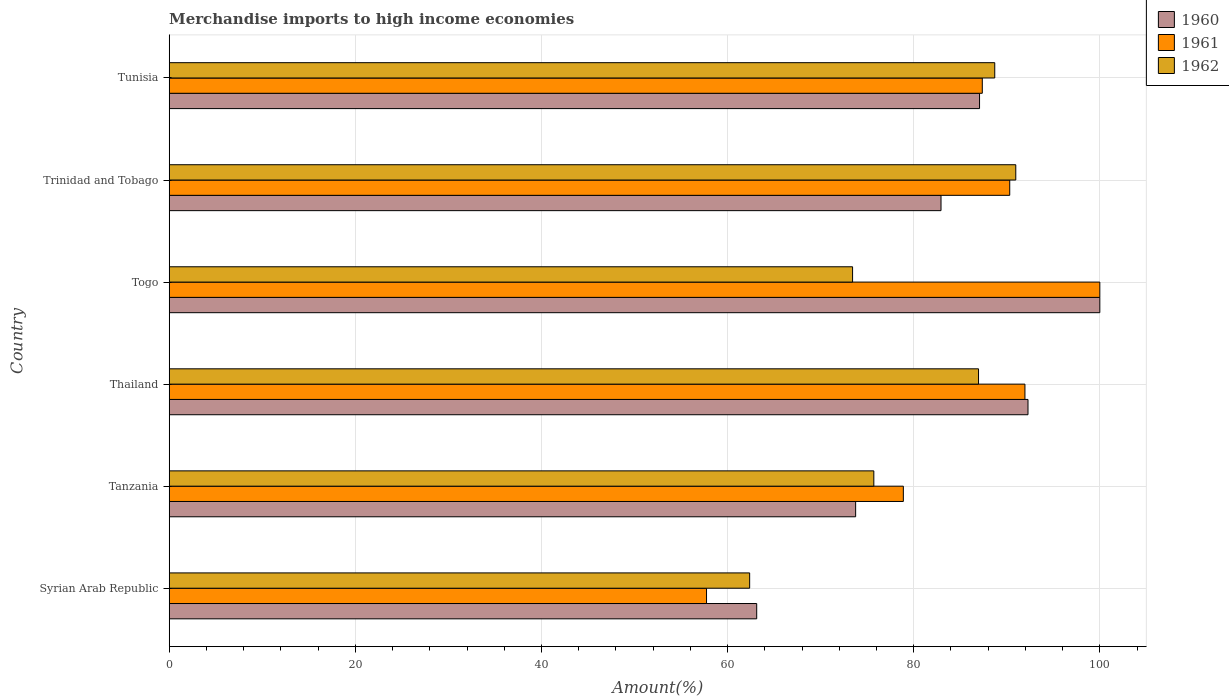How many different coloured bars are there?
Offer a very short reply. 3. How many bars are there on the 6th tick from the top?
Give a very brief answer. 3. How many bars are there on the 5th tick from the bottom?
Offer a very short reply. 3. What is the label of the 3rd group of bars from the top?
Your answer should be compact. Togo. In how many cases, is the number of bars for a given country not equal to the number of legend labels?
Keep it short and to the point. 0. What is the percentage of amount earned from merchandise imports in 1962 in Togo?
Your response must be concise. 73.43. Across all countries, what is the minimum percentage of amount earned from merchandise imports in 1961?
Make the answer very short. 57.74. In which country was the percentage of amount earned from merchandise imports in 1960 maximum?
Make the answer very short. Togo. In which country was the percentage of amount earned from merchandise imports in 1961 minimum?
Offer a terse response. Syrian Arab Republic. What is the total percentage of amount earned from merchandise imports in 1961 in the graph?
Keep it short and to the point. 506.26. What is the difference between the percentage of amount earned from merchandise imports in 1960 in Syrian Arab Republic and that in Tunisia?
Offer a very short reply. -23.95. What is the difference between the percentage of amount earned from merchandise imports in 1961 in Thailand and the percentage of amount earned from merchandise imports in 1962 in Trinidad and Tobago?
Your answer should be compact. 0.98. What is the average percentage of amount earned from merchandise imports in 1961 per country?
Your answer should be very brief. 84.38. What is the difference between the percentage of amount earned from merchandise imports in 1962 and percentage of amount earned from merchandise imports in 1961 in Tunisia?
Your response must be concise. 1.34. What is the ratio of the percentage of amount earned from merchandise imports in 1961 in Trinidad and Tobago to that in Tunisia?
Your answer should be compact. 1.03. Is the percentage of amount earned from merchandise imports in 1961 in Tanzania less than that in Tunisia?
Your answer should be very brief. Yes. Is the difference between the percentage of amount earned from merchandise imports in 1962 in Tanzania and Tunisia greater than the difference between the percentage of amount earned from merchandise imports in 1961 in Tanzania and Tunisia?
Ensure brevity in your answer.  No. What is the difference between the highest and the second highest percentage of amount earned from merchandise imports in 1960?
Your response must be concise. 7.72. What is the difference between the highest and the lowest percentage of amount earned from merchandise imports in 1961?
Your answer should be very brief. 42.26. Is the sum of the percentage of amount earned from merchandise imports in 1962 in Syrian Arab Republic and Thailand greater than the maximum percentage of amount earned from merchandise imports in 1961 across all countries?
Provide a succinct answer. Yes. Is it the case that in every country, the sum of the percentage of amount earned from merchandise imports in 1962 and percentage of amount earned from merchandise imports in 1961 is greater than the percentage of amount earned from merchandise imports in 1960?
Make the answer very short. Yes. How many bars are there?
Provide a short and direct response. 18. Are the values on the major ticks of X-axis written in scientific E-notation?
Keep it short and to the point. No. Does the graph contain any zero values?
Provide a succinct answer. No. Does the graph contain grids?
Keep it short and to the point. Yes. Where does the legend appear in the graph?
Your answer should be compact. Top right. How many legend labels are there?
Your answer should be compact. 3. What is the title of the graph?
Make the answer very short. Merchandise imports to high income economies. Does "1973" appear as one of the legend labels in the graph?
Offer a very short reply. No. What is the label or title of the X-axis?
Your response must be concise. Amount(%). What is the Amount(%) of 1960 in Syrian Arab Republic?
Provide a succinct answer. 63.13. What is the Amount(%) of 1961 in Syrian Arab Republic?
Your answer should be very brief. 57.74. What is the Amount(%) of 1962 in Syrian Arab Republic?
Keep it short and to the point. 62.37. What is the Amount(%) in 1960 in Tanzania?
Provide a succinct answer. 73.76. What is the Amount(%) in 1961 in Tanzania?
Provide a succinct answer. 78.89. What is the Amount(%) in 1962 in Tanzania?
Offer a terse response. 75.71. What is the Amount(%) of 1960 in Thailand?
Your answer should be very brief. 92.28. What is the Amount(%) in 1961 in Thailand?
Keep it short and to the point. 91.95. What is the Amount(%) of 1962 in Thailand?
Keep it short and to the point. 86.97. What is the Amount(%) of 1961 in Togo?
Provide a short and direct response. 100. What is the Amount(%) in 1962 in Togo?
Provide a short and direct response. 73.43. What is the Amount(%) of 1960 in Trinidad and Tobago?
Your response must be concise. 82.93. What is the Amount(%) in 1961 in Trinidad and Tobago?
Your response must be concise. 90.32. What is the Amount(%) of 1962 in Trinidad and Tobago?
Offer a very short reply. 90.97. What is the Amount(%) in 1960 in Tunisia?
Offer a very short reply. 87.07. What is the Amount(%) in 1961 in Tunisia?
Ensure brevity in your answer.  87.37. What is the Amount(%) in 1962 in Tunisia?
Offer a terse response. 88.71. Across all countries, what is the maximum Amount(%) of 1960?
Offer a very short reply. 100. Across all countries, what is the maximum Amount(%) in 1961?
Give a very brief answer. 100. Across all countries, what is the maximum Amount(%) in 1962?
Offer a very short reply. 90.97. Across all countries, what is the minimum Amount(%) of 1960?
Provide a succinct answer. 63.13. Across all countries, what is the minimum Amount(%) of 1961?
Offer a very short reply. 57.74. Across all countries, what is the minimum Amount(%) in 1962?
Give a very brief answer. 62.37. What is the total Amount(%) of 1960 in the graph?
Make the answer very short. 499.18. What is the total Amount(%) of 1961 in the graph?
Provide a short and direct response. 506.26. What is the total Amount(%) of 1962 in the graph?
Ensure brevity in your answer.  478.16. What is the difference between the Amount(%) in 1960 in Syrian Arab Republic and that in Tanzania?
Your answer should be compact. -10.63. What is the difference between the Amount(%) of 1961 in Syrian Arab Republic and that in Tanzania?
Give a very brief answer. -21.15. What is the difference between the Amount(%) in 1962 in Syrian Arab Republic and that in Tanzania?
Your response must be concise. -13.34. What is the difference between the Amount(%) in 1960 in Syrian Arab Republic and that in Thailand?
Provide a succinct answer. -29.15. What is the difference between the Amount(%) in 1961 in Syrian Arab Republic and that in Thailand?
Offer a very short reply. -34.21. What is the difference between the Amount(%) of 1962 in Syrian Arab Republic and that in Thailand?
Provide a short and direct response. -24.59. What is the difference between the Amount(%) in 1960 in Syrian Arab Republic and that in Togo?
Offer a terse response. -36.87. What is the difference between the Amount(%) in 1961 in Syrian Arab Republic and that in Togo?
Provide a succinct answer. -42.26. What is the difference between the Amount(%) of 1962 in Syrian Arab Republic and that in Togo?
Provide a succinct answer. -11.06. What is the difference between the Amount(%) in 1960 in Syrian Arab Republic and that in Trinidad and Tobago?
Give a very brief answer. -19.81. What is the difference between the Amount(%) in 1961 in Syrian Arab Republic and that in Trinidad and Tobago?
Make the answer very short. -32.58. What is the difference between the Amount(%) of 1962 in Syrian Arab Republic and that in Trinidad and Tobago?
Your answer should be very brief. -28.6. What is the difference between the Amount(%) of 1960 in Syrian Arab Republic and that in Tunisia?
Your response must be concise. -23.95. What is the difference between the Amount(%) in 1961 in Syrian Arab Republic and that in Tunisia?
Make the answer very short. -29.63. What is the difference between the Amount(%) in 1962 in Syrian Arab Republic and that in Tunisia?
Give a very brief answer. -26.34. What is the difference between the Amount(%) in 1960 in Tanzania and that in Thailand?
Ensure brevity in your answer.  -18.52. What is the difference between the Amount(%) in 1961 in Tanzania and that in Thailand?
Provide a short and direct response. -13.06. What is the difference between the Amount(%) of 1962 in Tanzania and that in Thailand?
Provide a short and direct response. -11.25. What is the difference between the Amount(%) of 1960 in Tanzania and that in Togo?
Provide a short and direct response. -26.24. What is the difference between the Amount(%) in 1961 in Tanzania and that in Togo?
Your answer should be compact. -21.11. What is the difference between the Amount(%) of 1962 in Tanzania and that in Togo?
Make the answer very short. 2.28. What is the difference between the Amount(%) of 1960 in Tanzania and that in Trinidad and Tobago?
Offer a terse response. -9.17. What is the difference between the Amount(%) of 1961 in Tanzania and that in Trinidad and Tobago?
Ensure brevity in your answer.  -11.43. What is the difference between the Amount(%) in 1962 in Tanzania and that in Trinidad and Tobago?
Make the answer very short. -15.25. What is the difference between the Amount(%) of 1960 in Tanzania and that in Tunisia?
Your answer should be very brief. -13.31. What is the difference between the Amount(%) of 1961 in Tanzania and that in Tunisia?
Offer a very short reply. -8.48. What is the difference between the Amount(%) in 1962 in Tanzania and that in Tunisia?
Keep it short and to the point. -12.99. What is the difference between the Amount(%) in 1960 in Thailand and that in Togo?
Your answer should be very brief. -7.72. What is the difference between the Amount(%) of 1961 in Thailand and that in Togo?
Your answer should be very brief. -8.05. What is the difference between the Amount(%) of 1962 in Thailand and that in Togo?
Offer a terse response. 13.53. What is the difference between the Amount(%) in 1960 in Thailand and that in Trinidad and Tobago?
Provide a succinct answer. 9.35. What is the difference between the Amount(%) in 1961 in Thailand and that in Trinidad and Tobago?
Ensure brevity in your answer.  1.63. What is the difference between the Amount(%) in 1962 in Thailand and that in Trinidad and Tobago?
Your answer should be compact. -4. What is the difference between the Amount(%) in 1960 in Thailand and that in Tunisia?
Provide a succinct answer. 5.21. What is the difference between the Amount(%) of 1961 in Thailand and that in Tunisia?
Offer a very short reply. 4.58. What is the difference between the Amount(%) of 1962 in Thailand and that in Tunisia?
Give a very brief answer. -1.74. What is the difference between the Amount(%) of 1960 in Togo and that in Trinidad and Tobago?
Your answer should be compact. 17.07. What is the difference between the Amount(%) of 1961 in Togo and that in Trinidad and Tobago?
Give a very brief answer. 9.68. What is the difference between the Amount(%) in 1962 in Togo and that in Trinidad and Tobago?
Offer a very short reply. -17.54. What is the difference between the Amount(%) in 1960 in Togo and that in Tunisia?
Your answer should be compact. 12.93. What is the difference between the Amount(%) in 1961 in Togo and that in Tunisia?
Give a very brief answer. 12.63. What is the difference between the Amount(%) in 1962 in Togo and that in Tunisia?
Offer a very short reply. -15.28. What is the difference between the Amount(%) in 1960 in Trinidad and Tobago and that in Tunisia?
Offer a very short reply. -4.14. What is the difference between the Amount(%) in 1961 in Trinidad and Tobago and that in Tunisia?
Your answer should be very brief. 2.95. What is the difference between the Amount(%) in 1962 in Trinidad and Tobago and that in Tunisia?
Provide a short and direct response. 2.26. What is the difference between the Amount(%) of 1960 in Syrian Arab Republic and the Amount(%) of 1961 in Tanzania?
Your answer should be compact. -15.76. What is the difference between the Amount(%) in 1960 in Syrian Arab Republic and the Amount(%) in 1962 in Tanzania?
Your response must be concise. -12.59. What is the difference between the Amount(%) in 1961 in Syrian Arab Republic and the Amount(%) in 1962 in Tanzania?
Ensure brevity in your answer.  -17.98. What is the difference between the Amount(%) of 1960 in Syrian Arab Republic and the Amount(%) of 1961 in Thailand?
Your response must be concise. -28.82. What is the difference between the Amount(%) of 1960 in Syrian Arab Republic and the Amount(%) of 1962 in Thailand?
Keep it short and to the point. -23.84. What is the difference between the Amount(%) in 1961 in Syrian Arab Republic and the Amount(%) in 1962 in Thailand?
Your response must be concise. -29.23. What is the difference between the Amount(%) in 1960 in Syrian Arab Republic and the Amount(%) in 1961 in Togo?
Offer a terse response. -36.87. What is the difference between the Amount(%) in 1960 in Syrian Arab Republic and the Amount(%) in 1962 in Togo?
Provide a succinct answer. -10.3. What is the difference between the Amount(%) in 1961 in Syrian Arab Republic and the Amount(%) in 1962 in Togo?
Your answer should be very brief. -15.69. What is the difference between the Amount(%) of 1960 in Syrian Arab Republic and the Amount(%) of 1961 in Trinidad and Tobago?
Your answer should be compact. -27.19. What is the difference between the Amount(%) of 1960 in Syrian Arab Republic and the Amount(%) of 1962 in Trinidad and Tobago?
Provide a short and direct response. -27.84. What is the difference between the Amount(%) of 1961 in Syrian Arab Republic and the Amount(%) of 1962 in Trinidad and Tobago?
Offer a very short reply. -33.23. What is the difference between the Amount(%) in 1960 in Syrian Arab Republic and the Amount(%) in 1961 in Tunisia?
Provide a short and direct response. -24.24. What is the difference between the Amount(%) in 1960 in Syrian Arab Republic and the Amount(%) in 1962 in Tunisia?
Offer a very short reply. -25.58. What is the difference between the Amount(%) in 1961 in Syrian Arab Republic and the Amount(%) in 1962 in Tunisia?
Offer a very short reply. -30.97. What is the difference between the Amount(%) of 1960 in Tanzania and the Amount(%) of 1961 in Thailand?
Provide a short and direct response. -18.19. What is the difference between the Amount(%) in 1960 in Tanzania and the Amount(%) in 1962 in Thailand?
Provide a short and direct response. -13.2. What is the difference between the Amount(%) of 1961 in Tanzania and the Amount(%) of 1962 in Thailand?
Provide a succinct answer. -8.08. What is the difference between the Amount(%) in 1960 in Tanzania and the Amount(%) in 1961 in Togo?
Provide a short and direct response. -26.24. What is the difference between the Amount(%) in 1960 in Tanzania and the Amount(%) in 1962 in Togo?
Your answer should be compact. 0.33. What is the difference between the Amount(%) of 1961 in Tanzania and the Amount(%) of 1962 in Togo?
Provide a short and direct response. 5.45. What is the difference between the Amount(%) of 1960 in Tanzania and the Amount(%) of 1961 in Trinidad and Tobago?
Your response must be concise. -16.56. What is the difference between the Amount(%) of 1960 in Tanzania and the Amount(%) of 1962 in Trinidad and Tobago?
Offer a very short reply. -17.21. What is the difference between the Amount(%) in 1961 in Tanzania and the Amount(%) in 1962 in Trinidad and Tobago?
Ensure brevity in your answer.  -12.08. What is the difference between the Amount(%) of 1960 in Tanzania and the Amount(%) of 1961 in Tunisia?
Offer a very short reply. -13.61. What is the difference between the Amount(%) of 1960 in Tanzania and the Amount(%) of 1962 in Tunisia?
Make the answer very short. -14.95. What is the difference between the Amount(%) of 1961 in Tanzania and the Amount(%) of 1962 in Tunisia?
Your answer should be compact. -9.82. What is the difference between the Amount(%) of 1960 in Thailand and the Amount(%) of 1961 in Togo?
Offer a terse response. -7.72. What is the difference between the Amount(%) of 1960 in Thailand and the Amount(%) of 1962 in Togo?
Offer a terse response. 18.85. What is the difference between the Amount(%) of 1961 in Thailand and the Amount(%) of 1962 in Togo?
Your answer should be compact. 18.52. What is the difference between the Amount(%) of 1960 in Thailand and the Amount(%) of 1961 in Trinidad and Tobago?
Keep it short and to the point. 1.96. What is the difference between the Amount(%) of 1960 in Thailand and the Amount(%) of 1962 in Trinidad and Tobago?
Provide a short and direct response. 1.31. What is the difference between the Amount(%) in 1960 in Thailand and the Amount(%) in 1961 in Tunisia?
Your answer should be compact. 4.91. What is the difference between the Amount(%) in 1960 in Thailand and the Amount(%) in 1962 in Tunisia?
Make the answer very short. 3.57. What is the difference between the Amount(%) in 1961 in Thailand and the Amount(%) in 1962 in Tunisia?
Your response must be concise. 3.24. What is the difference between the Amount(%) in 1960 in Togo and the Amount(%) in 1961 in Trinidad and Tobago?
Give a very brief answer. 9.68. What is the difference between the Amount(%) in 1960 in Togo and the Amount(%) in 1962 in Trinidad and Tobago?
Your response must be concise. 9.03. What is the difference between the Amount(%) in 1961 in Togo and the Amount(%) in 1962 in Trinidad and Tobago?
Provide a succinct answer. 9.03. What is the difference between the Amount(%) of 1960 in Togo and the Amount(%) of 1961 in Tunisia?
Your answer should be compact. 12.63. What is the difference between the Amount(%) of 1960 in Togo and the Amount(%) of 1962 in Tunisia?
Provide a succinct answer. 11.29. What is the difference between the Amount(%) in 1961 in Togo and the Amount(%) in 1962 in Tunisia?
Your answer should be very brief. 11.29. What is the difference between the Amount(%) in 1960 in Trinidad and Tobago and the Amount(%) in 1961 in Tunisia?
Ensure brevity in your answer.  -4.44. What is the difference between the Amount(%) of 1960 in Trinidad and Tobago and the Amount(%) of 1962 in Tunisia?
Offer a very short reply. -5.77. What is the difference between the Amount(%) in 1961 in Trinidad and Tobago and the Amount(%) in 1962 in Tunisia?
Provide a short and direct response. 1.61. What is the average Amount(%) of 1960 per country?
Your response must be concise. 83.2. What is the average Amount(%) in 1961 per country?
Offer a terse response. 84.38. What is the average Amount(%) of 1962 per country?
Keep it short and to the point. 79.69. What is the difference between the Amount(%) in 1960 and Amount(%) in 1961 in Syrian Arab Republic?
Provide a short and direct response. 5.39. What is the difference between the Amount(%) of 1960 and Amount(%) of 1962 in Syrian Arab Republic?
Give a very brief answer. 0.76. What is the difference between the Amount(%) of 1961 and Amount(%) of 1962 in Syrian Arab Republic?
Make the answer very short. -4.63. What is the difference between the Amount(%) in 1960 and Amount(%) in 1961 in Tanzania?
Offer a very short reply. -5.13. What is the difference between the Amount(%) of 1960 and Amount(%) of 1962 in Tanzania?
Make the answer very short. -1.95. What is the difference between the Amount(%) of 1961 and Amount(%) of 1962 in Tanzania?
Give a very brief answer. 3.17. What is the difference between the Amount(%) of 1960 and Amount(%) of 1961 in Thailand?
Your answer should be very brief. 0.33. What is the difference between the Amount(%) of 1960 and Amount(%) of 1962 in Thailand?
Your answer should be very brief. 5.32. What is the difference between the Amount(%) in 1961 and Amount(%) in 1962 in Thailand?
Provide a short and direct response. 4.99. What is the difference between the Amount(%) of 1960 and Amount(%) of 1962 in Togo?
Provide a succinct answer. 26.57. What is the difference between the Amount(%) of 1961 and Amount(%) of 1962 in Togo?
Your response must be concise. 26.57. What is the difference between the Amount(%) of 1960 and Amount(%) of 1961 in Trinidad and Tobago?
Give a very brief answer. -7.38. What is the difference between the Amount(%) in 1960 and Amount(%) in 1962 in Trinidad and Tobago?
Your answer should be very brief. -8.03. What is the difference between the Amount(%) of 1961 and Amount(%) of 1962 in Trinidad and Tobago?
Give a very brief answer. -0.65. What is the difference between the Amount(%) in 1960 and Amount(%) in 1961 in Tunisia?
Your response must be concise. -0.3. What is the difference between the Amount(%) in 1960 and Amount(%) in 1962 in Tunisia?
Make the answer very short. -1.63. What is the difference between the Amount(%) of 1961 and Amount(%) of 1962 in Tunisia?
Provide a succinct answer. -1.34. What is the ratio of the Amount(%) in 1960 in Syrian Arab Republic to that in Tanzania?
Offer a very short reply. 0.86. What is the ratio of the Amount(%) of 1961 in Syrian Arab Republic to that in Tanzania?
Provide a short and direct response. 0.73. What is the ratio of the Amount(%) in 1962 in Syrian Arab Republic to that in Tanzania?
Ensure brevity in your answer.  0.82. What is the ratio of the Amount(%) in 1960 in Syrian Arab Republic to that in Thailand?
Offer a terse response. 0.68. What is the ratio of the Amount(%) in 1961 in Syrian Arab Republic to that in Thailand?
Offer a terse response. 0.63. What is the ratio of the Amount(%) in 1962 in Syrian Arab Republic to that in Thailand?
Provide a short and direct response. 0.72. What is the ratio of the Amount(%) in 1960 in Syrian Arab Republic to that in Togo?
Make the answer very short. 0.63. What is the ratio of the Amount(%) of 1961 in Syrian Arab Republic to that in Togo?
Provide a succinct answer. 0.58. What is the ratio of the Amount(%) of 1962 in Syrian Arab Republic to that in Togo?
Keep it short and to the point. 0.85. What is the ratio of the Amount(%) of 1960 in Syrian Arab Republic to that in Trinidad and Tobago?
Provide a succinct answer. 0.76. What is the ratio of the Amount(%) of 1961 in Syrian Arab Republic to that in Trinidad and Tobago?
Make the answer very short. 0.64. What is the ratio of the Amount(%) of 1962 in Syrian Arab Republic to that in Trinidad and Tobago?
Offer a very short reply. 0.69. What is the ratio of the Amount(%) in 1960 in Syrian Arab Republic to that in Tunisia?
Your response must be concise. 0.72. What is the ratio of the Amount(%) in 1961 in Syrian Arab Republic to that in Tunisia?
Keep it short and to the point. 0.66. What is the ratio of the Amount(%) of 1962 in Syrian Arab Republic to that in Tunisia?
Your answer should be very brief. 0.7. What is the ratio of the Amount(%) of 1960 in Tanzania to that in Thailand?
Make the answer very short. 0.8. What is the ratio of the Amount(%) in 1961 in Tanzania to that in Thailand?
Make the answer very short. 0.86. What is the ratio of the Amount(%) in 1962 in Tanzania to that in Thailand?
Give a very brief answer. 0.87. What is the ratio of the Amount(%) in 1960 in Tanzania to that in Togo?
Your response must be concise. 0.74. What is the ratio of the Amount(%) in 1961 in Tanzania to that in Togo?
Give a very brief answer. 0.79. What is the ratio of the Amount(%) of 1962 in Tanzania to that in Togo?
Offer a very short reply. 1.03. What is the ratio of the Amount(%) of 1960 in Tanzania to that in Trinidad and Tobago?
Make the answer very short. 0.89. What is the ratio of the Amount(%) of 1961 in Tanzania to that in Trinidad and Tobago?
Offer a very short reply. 0.87. What is the ratio of the Amount(%) in 1962 in Tanzania to that in Trinidad and Tobago?
Make the answer very short. 0.83. What is the ratio of the Amount(%) of 1960 in Tanzania to that in Tunisia?
Your answer should be compact. 0.85. What is the ratio of the Amount(%) of 1961 in Tanzania to that in Tunisia?
Provide a short and direct response. 0.9. What is the ratio of the Amount(%) in 1962 in Tanzania to that in Tunisia?
Provide a succinct answer. 0.85. What is the ratio of the Amount(%) in 1960 in Thailand to that in Togo?
Offer a very short reply. 0.92. What is the ratio of the Amount(%) of 1961 in Thailand to that in Togo?
Your answer should be compact. 0.92. What is the ratio of the Amount(%) in 1962 in Thailand to that in Togo?
Provide a short and direct response. 1.18. What is the ratio of the Amount(%) of 1960 in Thailand to that in Trinidad and Tobago?
Make the answer very short. 1.11. What is the ratio of the Amount(%) in 1961 in Thailand to that in Trinidad and Tobago?
Offer a terse response. 1.02. What is the ratio of the Amount(%) in 1962 in Thailand to that in Trinidad and Tobago?
Offer a very short reply. 0.96. What is the ratio of the Amount(%) in 1960 in Thailand to that in Tunisia?
Give a very brief answer. 1.06. What is the ratio of the Amount(%) in 1961 in Thailand to that in Tunisia?
Offer a very short reply. 1.05. What is the ratio of the Amount(%) of 1962 in Thailand to that in Tunisia?
Offer a very short reply. 0.98. What is the ratio of the Amount(%) of 1960 in Togo to that in Trinidad and Tobago?
Offer a terse response. 1.21. What is the ratio of the Amount(%) of 1961 in Togo to that in Trinidad and Tobago?
Your answer should be very brief. 1.11. What is the ratio of the Amount(%) in 1962 in Togo to that in Trinidad and Tobago?
Your answer should be compact. 0.81. What is the ratio of the Amount(%) of 1960 in Togo to that in Tunisia?
Provide a succinct answer. 1.15. What is the ratio of the Amount(%) in 1961 in Togo to that in Tunisia?
Ensure brevity in your answer.  1.14. What is the ratio of the Amount(%) of 1962 in Togo to that in Tunisia?
Offer a very short reply. 0.83. What is the ratio of the Amount(%) of 1960 in Trinidad and Tobago to that in Tunisia?
Provide a succinct answer. 0.95. What is the ratio of the Amount(%) in 1961 in Trinidad and Tobago to that in Tunisia?
Ensure brevity in your answer.  1.03. What is the ratio of the Amount(%) of 1962 in Trinidad and Tobago to that in Tunisia?
Give a very brief answer. 1.03. What is the difference between the highest and the second highest Amount(%) in 1960?
Your response must be concise. 7.72. What is the difference between the highest and the second highest Amount(%) of 1961?
Make the answer very short. 8.05. What is the difference between the highest and the second highest Amount(%) of 1962?
Keep it short and to the point. 2.26. What is the difference between the highest and the lowest Amount(%) of 1960?
Provide a short and direct response. 36.87. What is the difference between the highest and the lowest Amount(%) in 1961?
Your response must be concise. 42.26. What is the difference between the highest and the lowest Amount(%) of 1962?
Offer a terse response. 28.6. 